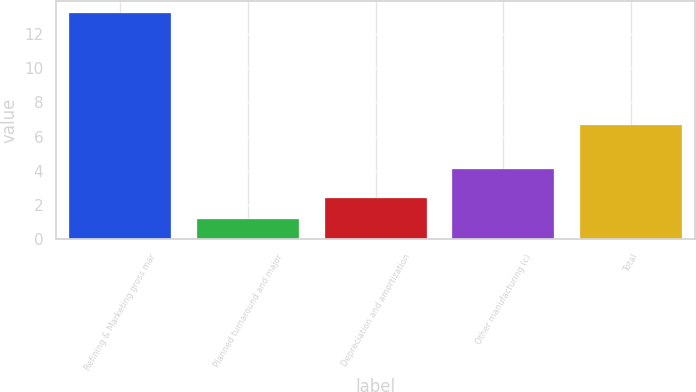Convert chart. <chart><loc_0><loc_0><loc_500><loc_500><bar_chart><fcel>Refining & Marketing gross mar<fcel>Planned turnaround and major<fcel>Depreciation and amortization<fcel>Other manufacturing (c)<fcel>Total<nl><fcel>13.24<fcel>1.2<fcel>2.4<fcel>4.14<fcel>6.7<nl></chart> 